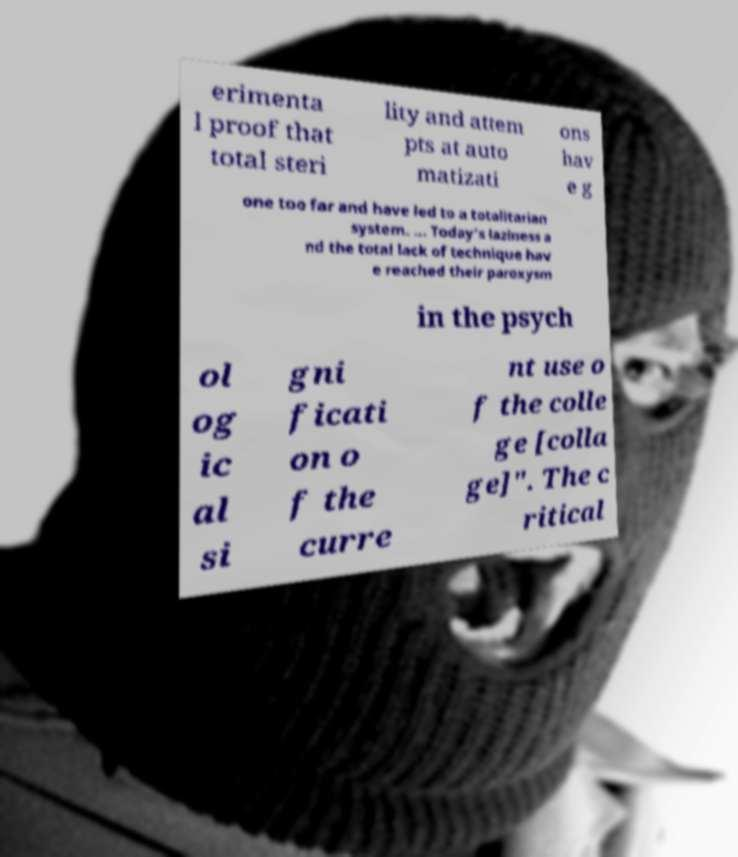Please read and relay the text visible in this image. What does it say? erimenta l proof that total steri lity and attem pts at auto matizati ons hav e g one too far and have led to a totalitarian system. ... Today's laziness a nd the total lack of technique hav e reached their paroxysm in the psych ol og ic al si gni ficati on o f the curre nt use o f the colle ge [colla ge]". The c ritical 